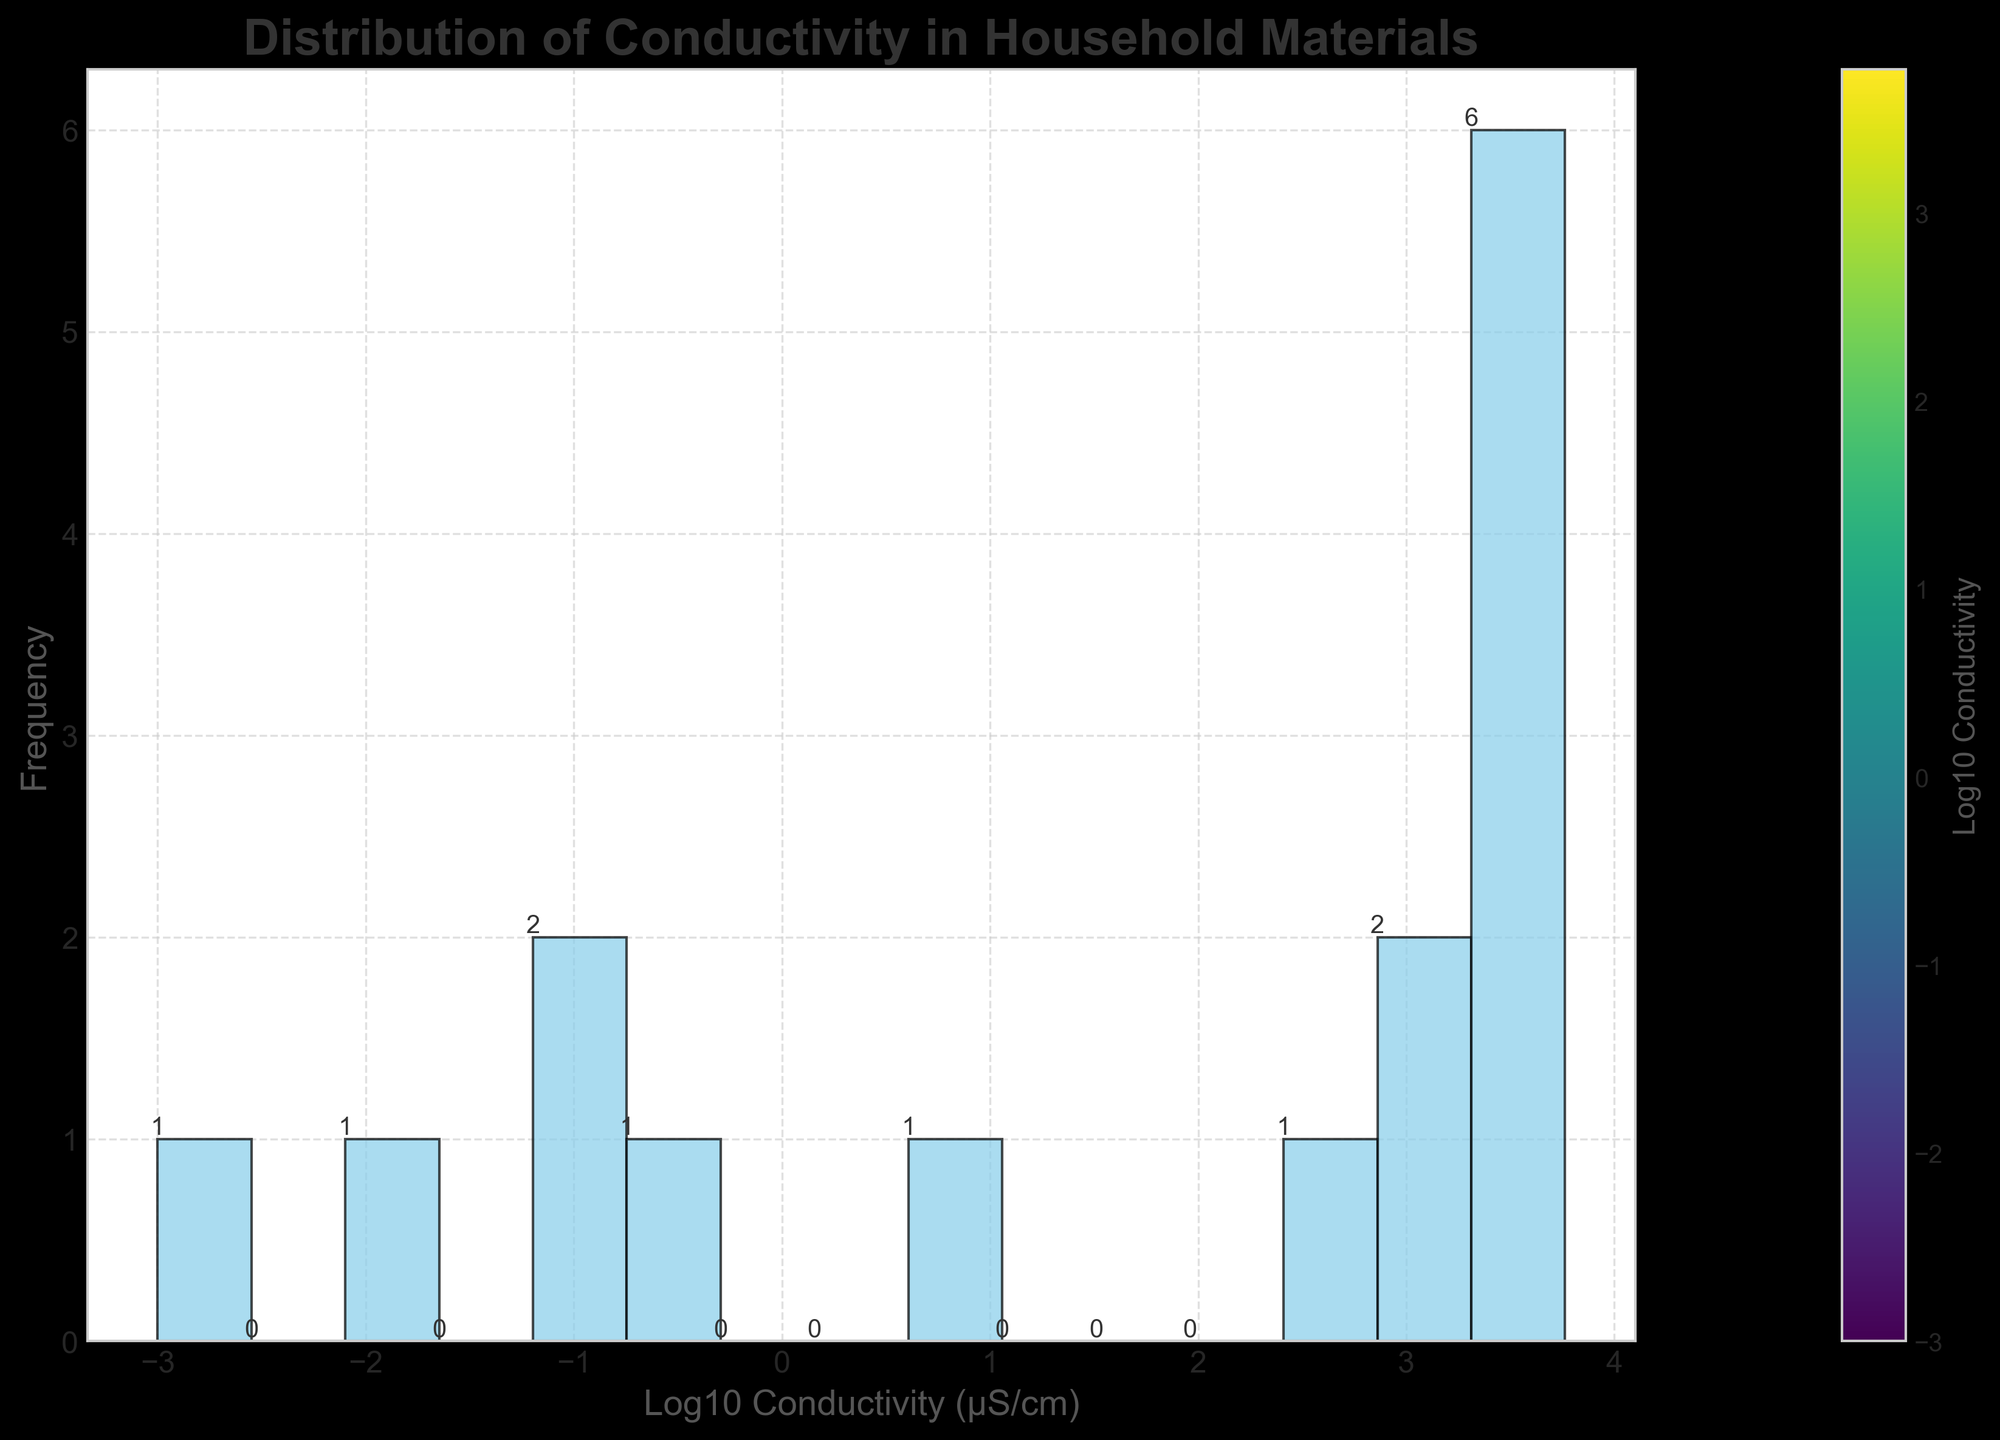What is the title of the histogram? The title is displayed at the top of the figure. It usually describes what the figure is about.
Answer: Distribution of Conductivity in Household Materials What does the x-axis represent? The x-axis label is located at the bottom of the chart and describes the variable being measured.
Answer: Log10 Conductivity (μS/cm) How many bins are there in the histogram? Bins are the individual bars in the histogram. You can count them directly from the figure.
Answer: 15 What is the frequency of the bin with the highest bar? The bin with the highest bar represents the mode of the distribution. The frequency is written above the highest bar.
Answer: 3 Which material has the lowest conductivity? The lowest value on the x-axis corresponds to the material with the lowest conductivity.
Answer: Glass What is the frequency of materials with conductivity above 1000 μS/cm? To find this, you first identify all bins that fall above the log10 of 1000 (log10(1000) ≈ 3). Then you sum the frequencies of those bins.
Answer: 10 How does the conductivity of Tap Water compare to that of Distilled Water? Check the positions of the bins corresponding to the logarithm of Tap Water (log10(350) ≈ 2.54) and Distilled Water (log10(5) ≈ 0.7).
Answer: Tap Water is higher What is the difference between the highest and lowest log10 conductivity values? Determine the log10 values at the two extremes of the x-axis (highest bin and lowest bin), then calculate the difference.
Answer: About 4 (highest ~3.76, lowest ~-3) What can you infer about the distribution of conductivity in household materials? Look at the shape and spread of the histogram. A majority of materials fall within certain log10 conductivity ranges.
Answer: It is right-skewed What is the overall trend depicted by the histogram? The overall pattern of the histogram can be observed by looking at the heights of the bins across the x-axis.
Answer: Most materials have low to moderate conductivity 